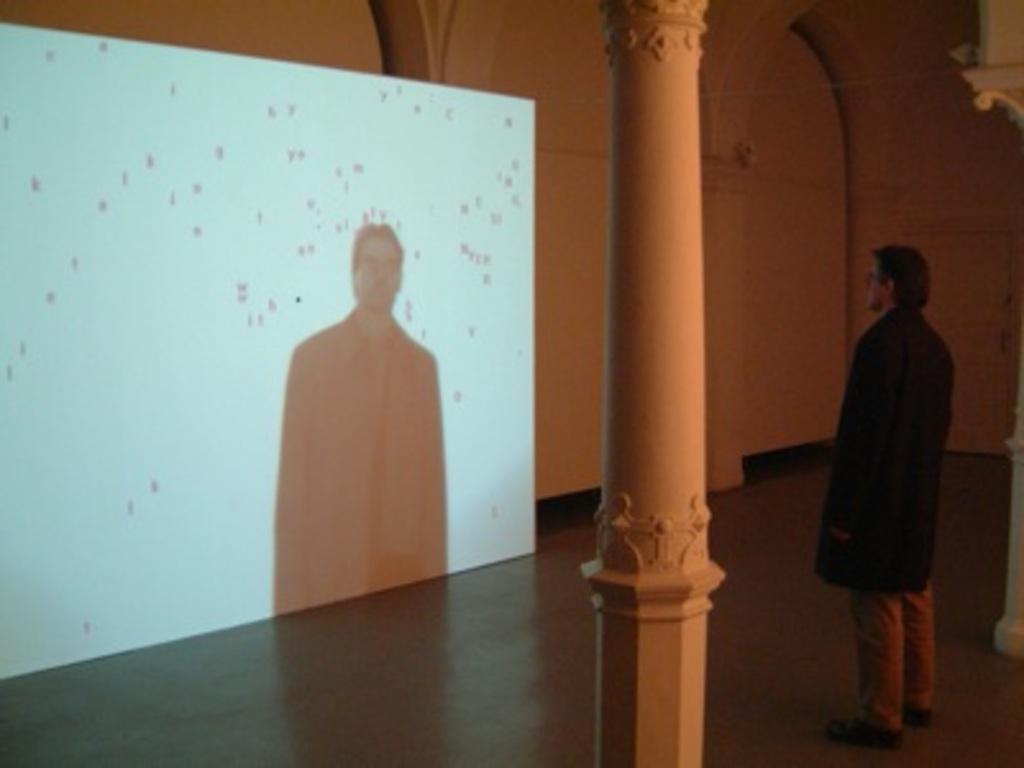Describe this image in one or two sentences. In this image we can see the projector display, man standing on the floor, walls, pillars and electric notch. 